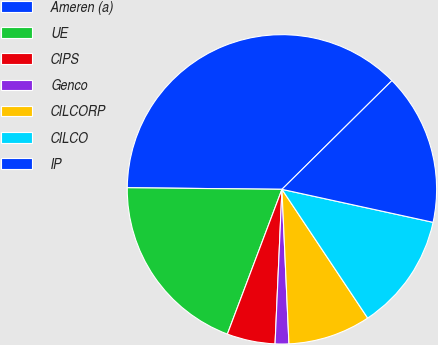<chart> <loc_0><loc_0><loc_500><loc_500><pie_chart><fcel>Ameren (a)<fcel>UE<fcel>CIPS<fcel>Genco<fcel>CILCORP<fcel>CILCO<fcel>IP<nl><fcel>37.43%<fcel>19.43%<fcel>5.03%<fcel>1.43%<fcel>8.63%<fcel>12.23%<fcel>15.83%<nl></chart> 